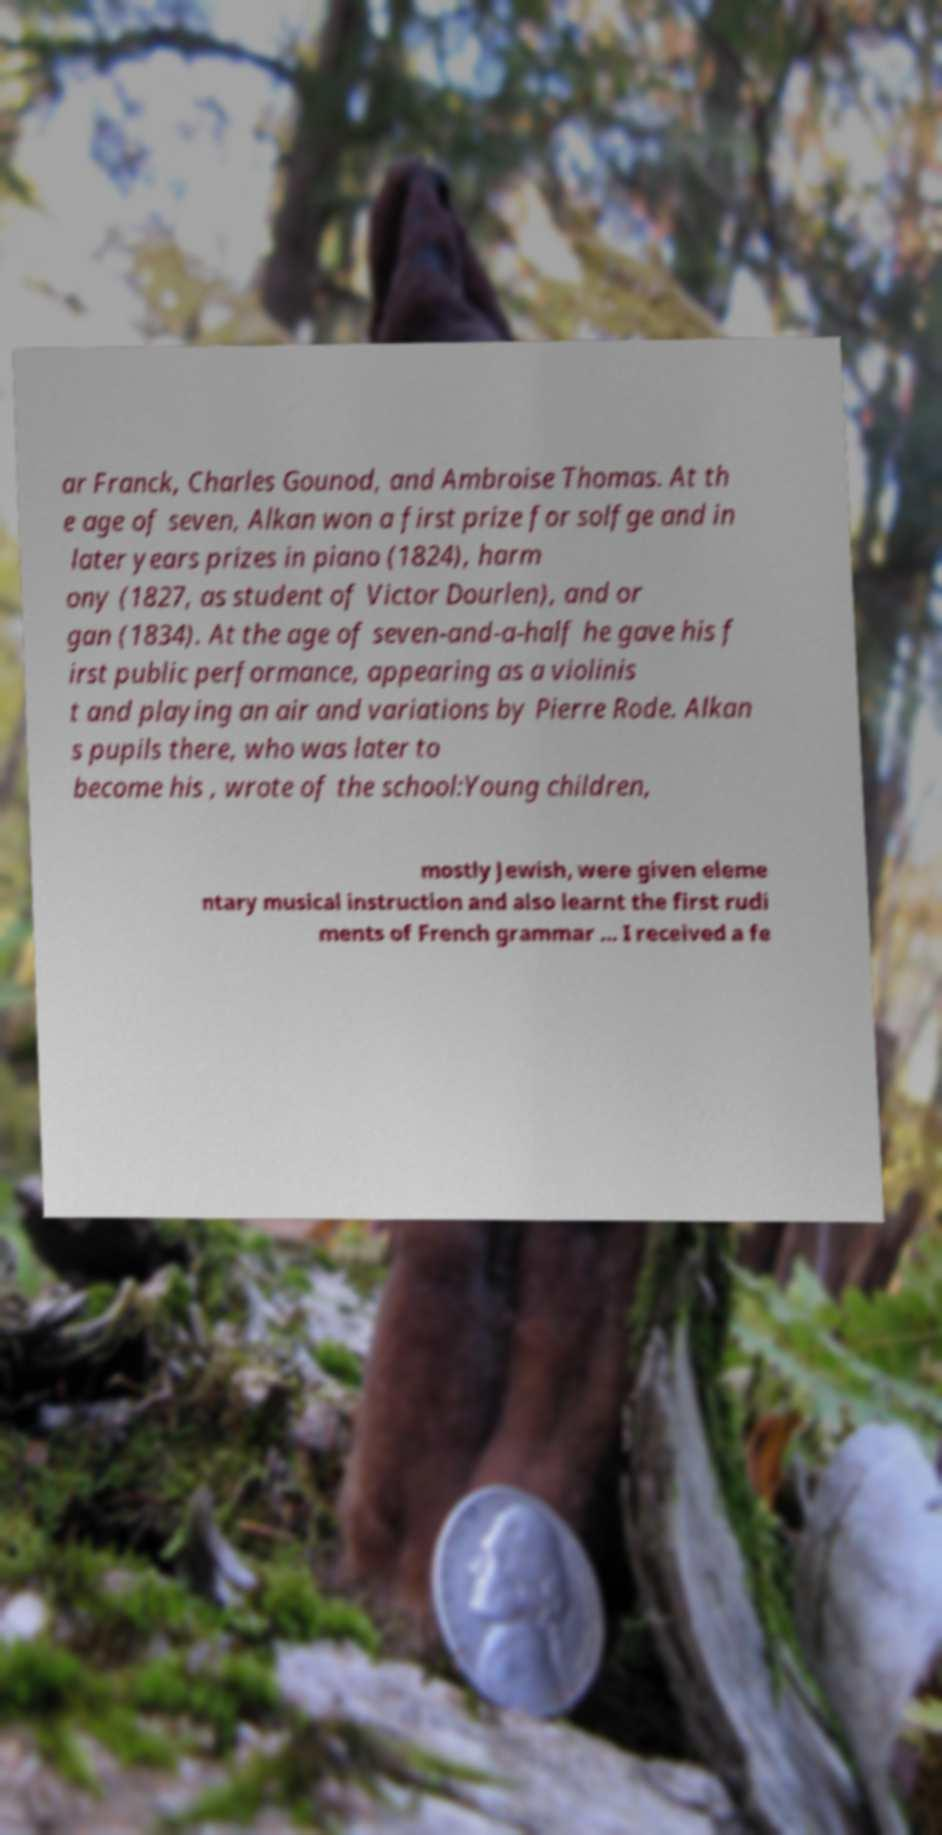Please identify and transcribe the text found in this image. ar Franck, Charles Gounod, and Ambroise Thomas. At th e age of seven, Alkan won a first prize for solfge and in later years prizes in piano (1824), harm ony (1827, as student of Victor Dourlen), and or gan (1834). At the age of seven-and-a-half he gave his f irst public performance, appearing as a violinis t and playing an air and variations by Pierre Rode. Alkan s pupils there, who was later to become his , wrote of the school:Young children, mostly Jewish, were given eleme ntary musical instruction and also learnt the first rudi ments of French grammar ... I received a fe 